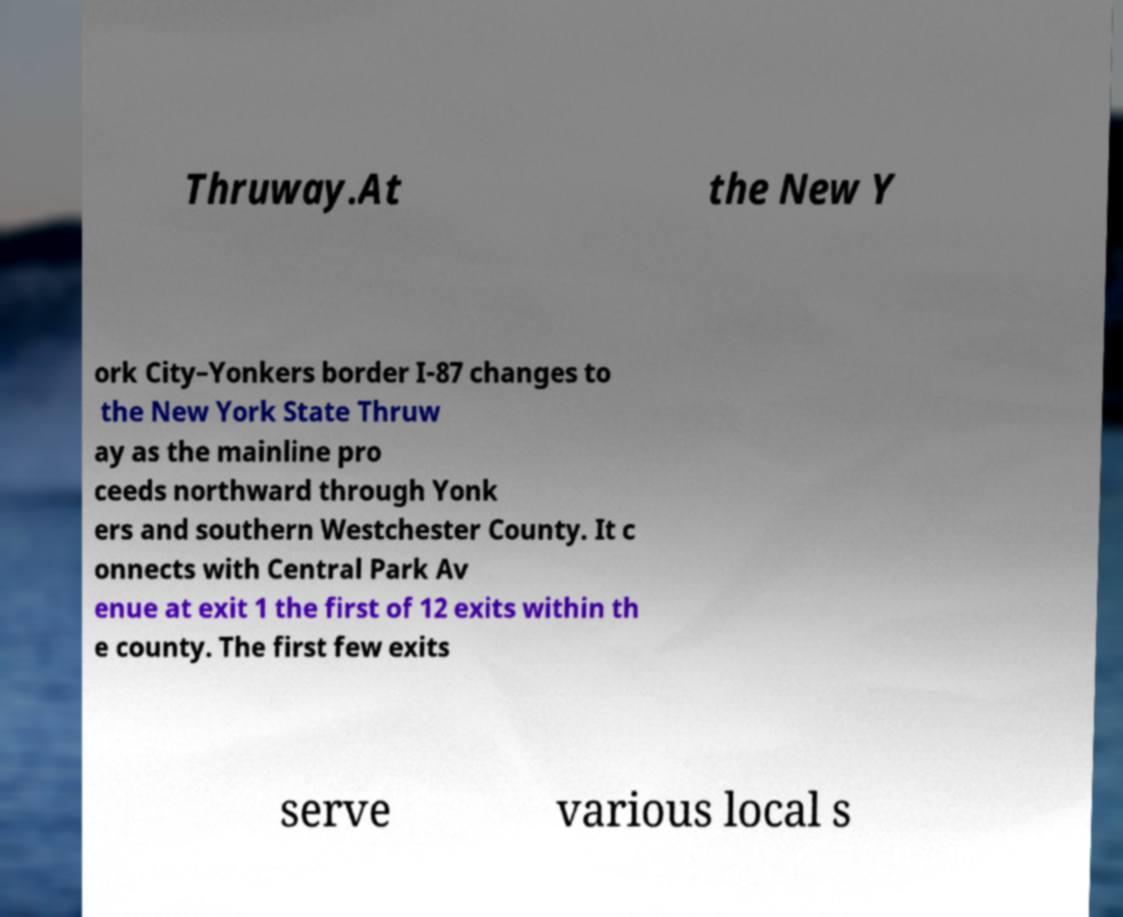For documentation purposes, I need the text within this image transcribed. Could you provide that? Thruway.At the New Y ork City–Yonkers border I-87 changes to the New York State Thruw ay as the mainline pro ceeds northward through Yonk ers and southern Westchester County. It c onnects with Central Park Av enue at exit 1 the first of 12 exits within th e county. The first few exits serve various local s 